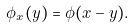Convert formula to latex. <formula><loc_0><loc_0><loc_500><loc_500>\phi _ { x } ( y ) = \phi ( x - y ) .</formula> 